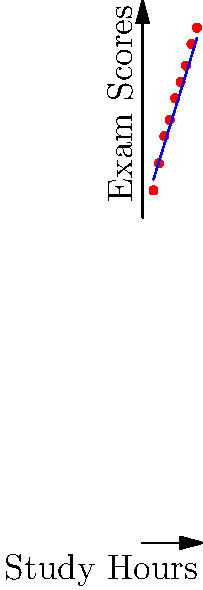Based on the scatter plot showing the relationship between study hours and exam scores for a group of students, which machine learning algorithm would be most appropriate for predicting a student's exam score given their study hours? To determine the most appropriate machine learning algorithm, we need to analyze the scatter plot:

1. Observe the data distribution:
   - The points form a roughly linear pattern from bottom-left to top-right.
   - There's a clear positive correlation between study hours and exam scores.

2. Consider the nature of the problem:
   - We want to predict a continuous value (exam score) based on an input variable (study hours).
   - This is a regression problem, not a classification problem.

3. Evaluate the relationship:
   - The relationship appears to be approximately linear.
   - There's no evident non-linear pattern or complex curvature in the data.

4. Consider the simplicity and interpretability:
   - As an academic advisor, you'd likely prefer a model that's easy to explain to students and colleagues.

5. Match the problem characteristics to machine learning algorithms:
   - Linear Regression would be suitable for this scenario because:
     a) It models linear relationships between variables.
     b) It's used for predicting continuous outcomes.
     c) It's simple to understand and explain.
     d) It performs well with clear linear trends like the one shown.

Therefore, given the linear trend in the data and the need for a straightforward, interpretable model for predicting exam scores based on study hours, Linear Regression would be the most appropriate machine learning algorithm for this scenario.
Answer: Linear Regression 